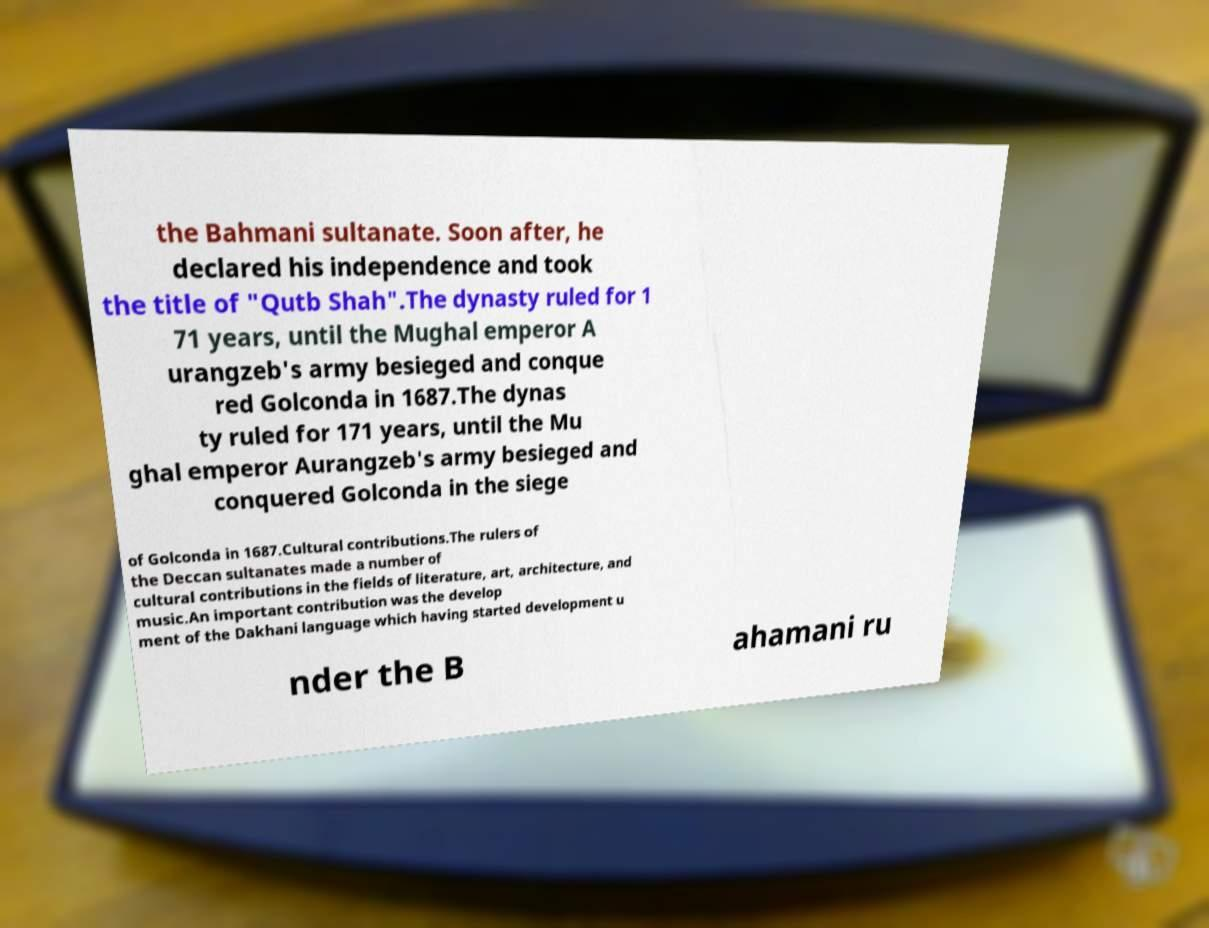Could you extract and type out the text from this image? the Bahmani sultanate. Soon after, he declared his independence and took the title of "Qutb Shah".The dynasty ruled for 1 71 years, until the Mughal emperor A urangzeb's army besieged and conque red Golconda in 1687.The dynas ty ruled for 171 years, until the Mu ghal emperor Aurangzeb's army besieged and conquered Golconda in the siege of Golconda in 1687.Cultural contributions.The rulers of the Deccan sultanates made a number of cultural contributions in the fields of literature, art, architecture, and music.An important contribution was the develop ment of the Dakhani language which having started development u nder the B ahamani ru 